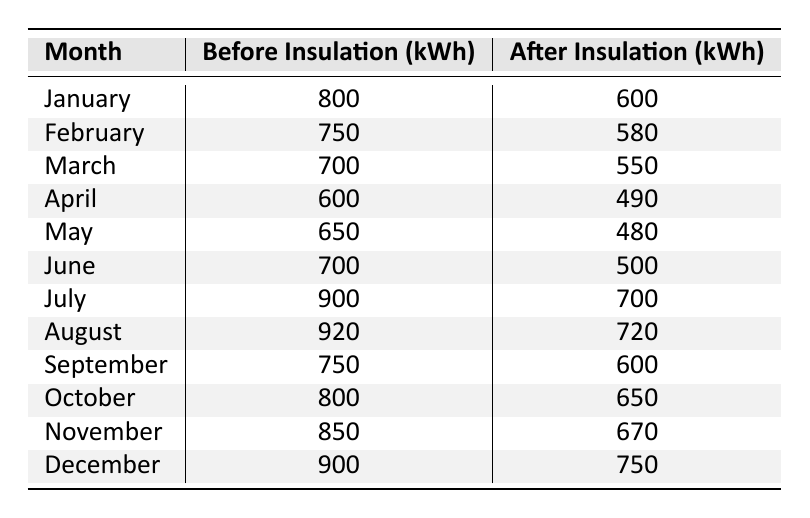What is the energy consumption in January before insulation installation? The table shows that the energy consumption in January before insulation installation is listed as 800 kWh.
Answer: 800 kWh What is the energy consumption in June after insulation installation? According to the table, the energy consumption in June after insulation installation is listed as 500 kWh.
Answer: 500 kWh What is the difference in energy consumption for February before and after insulation installation? For February, before insulation is 750 kWh and after is 580 kWh. The difference is calculated as 750 - 580 = 170 kWh.
Answer: 170 kWh What month had the highest energy consumption after insulation installation? By examining the after insulation values, December has the highest energy consumption at 750 kWh.
Answer: December What is the total energy consumption across all months before insulation installation? Summing up the before insulation values: 800 + 750 + 700 + 600 + 650 + 700 + 900 + 920 + 750 + 800 + 850 + 900 = 8,620 kWh.
Answer: 8620 kWh Is the statement "April had lower energy consumption after insulation compared to February" true? April after insulation consumption is 490 kWh, while February is at 580 kWh; since 490 is less than 580, the statement is true.
Answer: Yes What is the average energy consumption before insulation installation? To find the average, sum all before values (8620 kWh) and divide by the number of months (12): 8620 / 12 = 718.33 kWh (rounded to 2 decimal places).
Answer: 718.33 kWh What is the total reduction in energy consumption from before to after insulation for all months? Calculating the total for before (8620 kWh) and after (7300 kWh), the reduction is 8620 - 7300 = 1320 kWh.
Answer: 1320 kWh Which month had the least reduction in energy consumption after insulation installation? By checking the differences for all months, the least reduction is in February with 170 kWh (750 - 580).
Answer: February What was the energy consumption after insulation installation in July? The table shows that the energy consumption after insulation installation in July is 700 kWh.
Answer: 700 kWh 